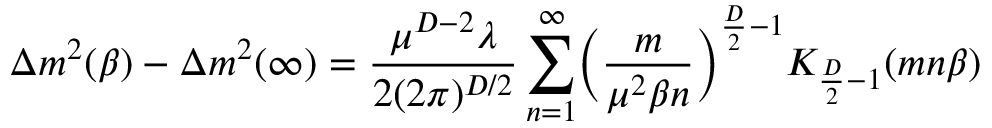Convert formula to latex. <formula><loc_0><loc_0><loc_500><loc_500>\Delta m ^ { 2 } ( \beta ) - \Delta m ^ { 2 } ( \infty ) = \frac { \mu ^ { D - 2 } \lambda } { 2 ( 2 \pi ) ^ { D / 2 } } \sum _ { n = 1 } ^ { \infty } \left ( \frac { m } { \mu ^ { 2 } \beta n } \right ) ^ { \frac { D } { 2 } - 1 } K _ { \frac { D } { 2 } - 1 } ( m n \beta )</formula> 